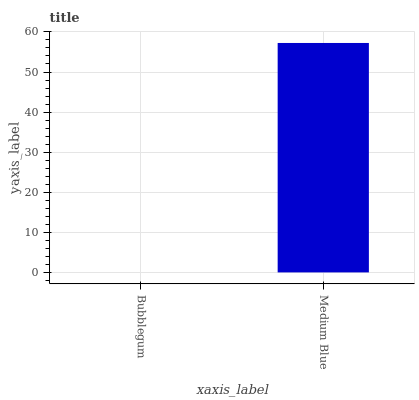Is Medium Blue the minimum?
Answer yes or no. No. Is Medium Blue greater than Bubblegum?
Answer yes or no. Yes. Is Bubblegum less than Medium Blue?
Answer yes or no. Yes. Is Bubblegum greater than Medium Blue?
Answer yes or no. No. Is Medium Blue less than Bubblegum?
Answer yes or no. No. Is Medium Blue the high median?
Answer yes or no. Yes. Is Bubblegum the low median?
Answer yes or no. Yes. Is Bubblegum the high median?
Answer yes or no. No. Is Medium Blue the low median?
Answer yes or no. No. 